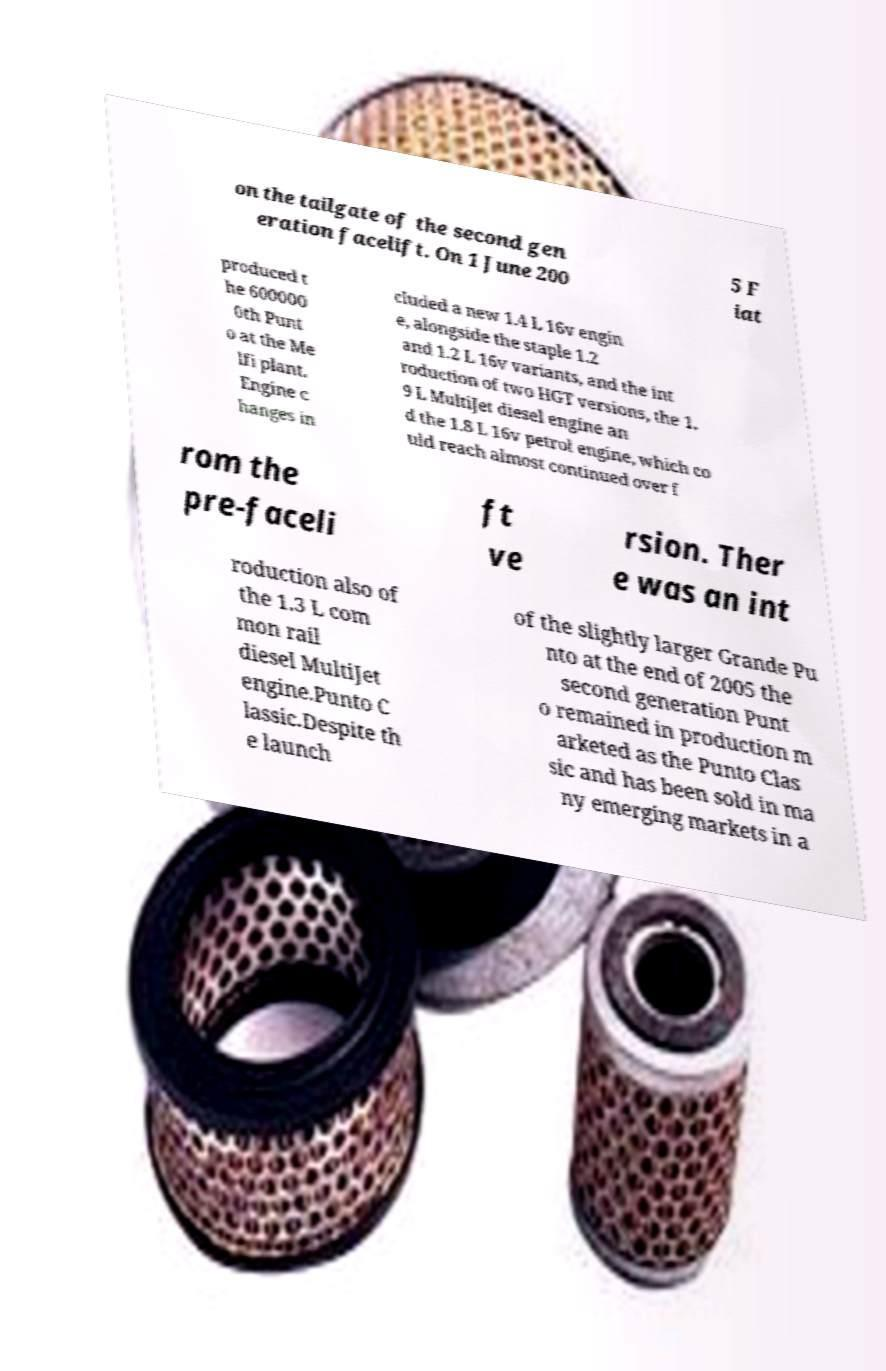For documentation purposes, I need the text within this image transcribed. Could you provide that? on the tailgate of the second gen eration facelift. On 1 June 200 5 F iat produced t he 600000 0th Punt o at the Me lfi plant. Engine c hanges in cluded a new 1.4 L 16v engin e, alongside the staple 1.2 and 1.2 L 16v variants, and the int roduction of two HGT versions, the 1. 9 L MultiJet diesel engine an d the 1.8 L 16v petrol engine, which co uld reach almost continued over f rom the pre-faceli ft ve rsion. Ther e was an int roduction also of the 1.3 L com mon rail diesel MultiJet engine.Punto C lassic.Despite th e launch of the slightly larger Grande Pu nto at the end of 2005 the second generation Punt o remained in production m arketed as the Punto Clas sic and has been sold in ma ny emerging markets in a 